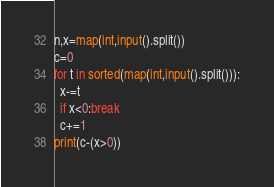Convert code to text. <code><loc_0><loc_0><loc_500><loc_500><_Python_>n,x=map(int,input().split())
c=0
for t in sorted(map(int,input().split())):
  x-=t
  if x<0:break
  c+=1
print(c-(x>0))</code> 